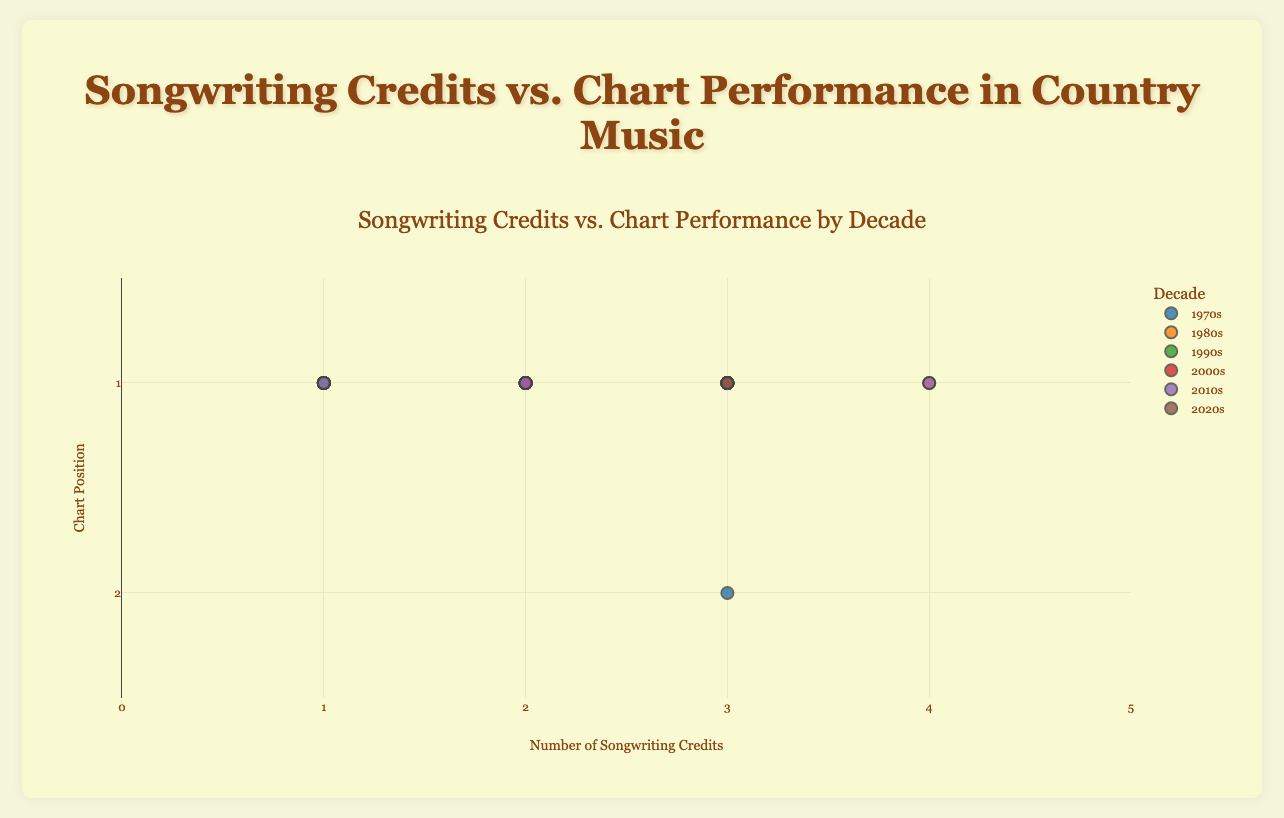What is the title of the chart? The title of the chart is prominently displayed at the top and reads "Songwriting Credits vs. Chart Performance by Decade".
Answer: Songwriting Credits vs. Chart Performance by Decade What does the x-axis represent? The x-axis is labeled "Number of Songwriting Credits", indicating it represents the count of songwriting credits per song.
Answer: Number of Songwriting Credits Which decade shows the highest number of data points with 3 songwriting credits? From a visual scan of the grouped scatter plot, the 2020s decade shows multiple data points clustered at the 3 songwriting credits mark.
Answer: 2020s What is the chart position range displayed on the y-axis? The y-axis, labeled "Chart Position", has a range from 0.5 (top of the chart) to 2.5 (bottom of the chart), focusing on the top chart positions.
Answer: 0.5 to 2.5 How many songs from the 1970s have exactly 1 songwriting credit? From the data markers on the 1970s trace, there are four songs placed at the 1 songwriting credit mark—namely "Jolene", "Coal Miner's Daughter", "The Gambler", and "Rhinestone Cowboy".
Answer: 4 Are there any data points in the 1980s with 4 songwriting credits? Observing the plot, there is a single data point in the 1980s cluster which is "Islands in the Stream" marked at 4 songwriting credits.
Answer: Yes Which decade had no songs with 1 songwriting credit? By visually inspecting the scatter plot, both the 2000s and the 2020s decades have data points but none positioned at the 1 songwriting credit level.
Answer: 2000s and 2020s How do the chart positions for songs with 2 songwriting credits compare across different decades? Songs with 2 songwriting credits consistently land at the number 1 chart position across all relevant decades as seen on the plot.
Answer: Number 1 for each decade Which decade has the most diverse range of songwriting credits for top-charting songs? The 2010s show the most substantial spread, from songs with 1 up to 4 songwriting credits, all charting at number 1 positions.
Answer: 2010s How does the number of songs with more than 2 songwriting credits change over the decades? Starting from no songs with more than 2 credits in the 1970s, the number gradually increases, with decades 2000s, 2010s, 2020s showing data points at 3 and 4 credits.
Answer: Increases over time 